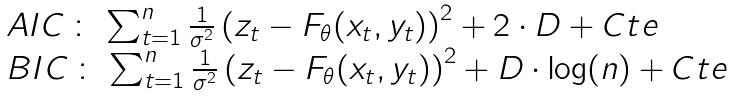Convert formula to latex. <formula><loc_0><loc_0><loc_500><loc_500>\begin{array} { l } A I C \, \colon \, \sum _ { t = 1 } ^ { n } \frac { 1 } { \sigma ^ { 2 } } \left ( z _ { t } - F _ { \theta } ( x _ { t } , y _ { t } ) \right ) ^ { 2 } + 2 \cdot D + C t e \\ B I C \, \colon \, \sum _ { t = 1 } ^ { n } \frac { 1 } { \sigma ^ { 2 } } \left ( z _ { t } - F _ { \theta } ( x _ { t } , y _ { t } ) \right ) ^ { 2 } + D \cdot \log ( n ) + C t e \\ \end{array}</formula> 